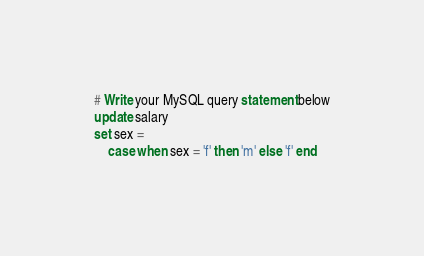<code> <loc_0><loc_0><loc_500><loc_500><_SQL_># Write your MySQL query statement below
update salary
set sex = 
    case when sex = 'f' then 'm' else 'f' end
</code> 